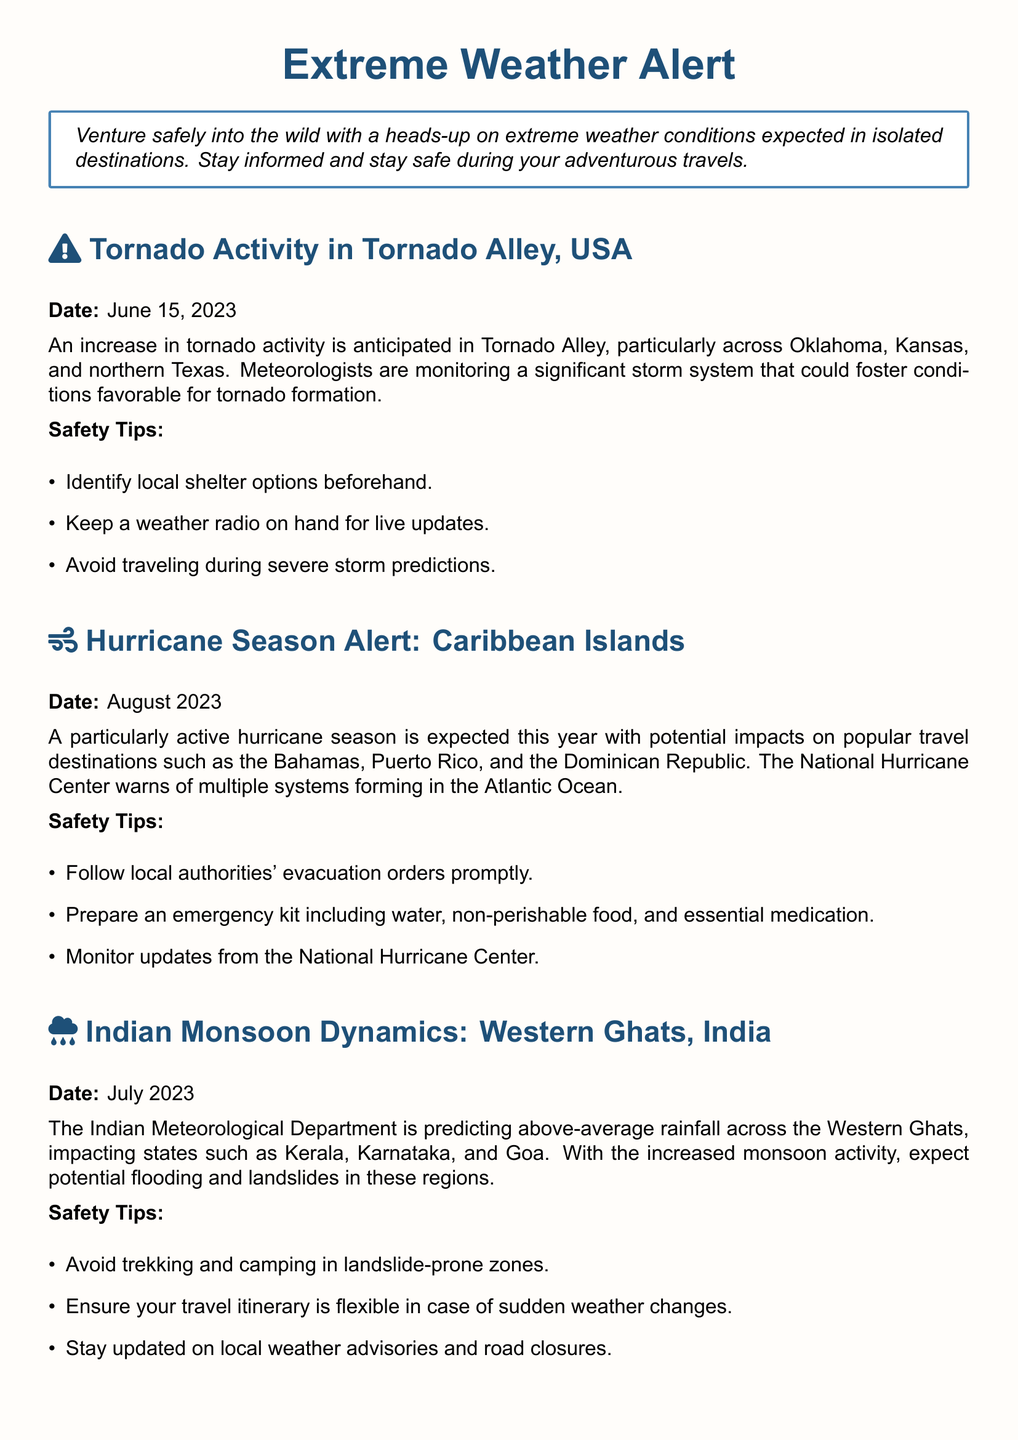What is the date of the tornado activity alert? The tornado activity alert is dated June 15, 2023, as mentioned in the section.
Answer: June 15, 2023 Which states are mentioned in the tornado alert? The alert discusses tornado activity particularly in Oklahoma, Kansas, and northern Texas.
Answer: Oklahoma, Kansas, northern Texas What do meteorologists anticipate in Tornado Alley? Meteorologists are monitoring a significant storm system that could foster conditions favorable for tornado formation.
Answer: Tornado formation What month is associated with the hurricane season alert? The hurricane season alert is associated with August 2023, as stated in the document.
Answer: August 2023 Name one of the Caribbean destinations mentioned for hurricane impacts. The document mentions the Bahamas as one of the Caribbean destinations impacted by the hurricane season.
Answer: Bahamas What is a key safety tip in the hurricane section? One safety tip is to follow local authorities' evacuation orders promptly, which is critical during a hurricane.
Answer: Follow local authorities' evacuation orders What is predicted for the Western Ghats in July 2023? The Indian Meteorological Department predicts above-average rainfall for the Western Ghats, impacting several states.
Answer: Above-average rainfall What should travelers avoid during the monsoon according to the safety tips? Travelers are advised to avoid trekking and camping in landslide-prone zones during the monsoon period.
Answer: Trekking and camping in landslide-prone zones How should travelers prepare for extreme weather conditions? Travelers are advised to check weather forecasts regularly and have contingency plans in place for extreme conditions.
Answer: Check weather forecasts regularly and have contingency plans 